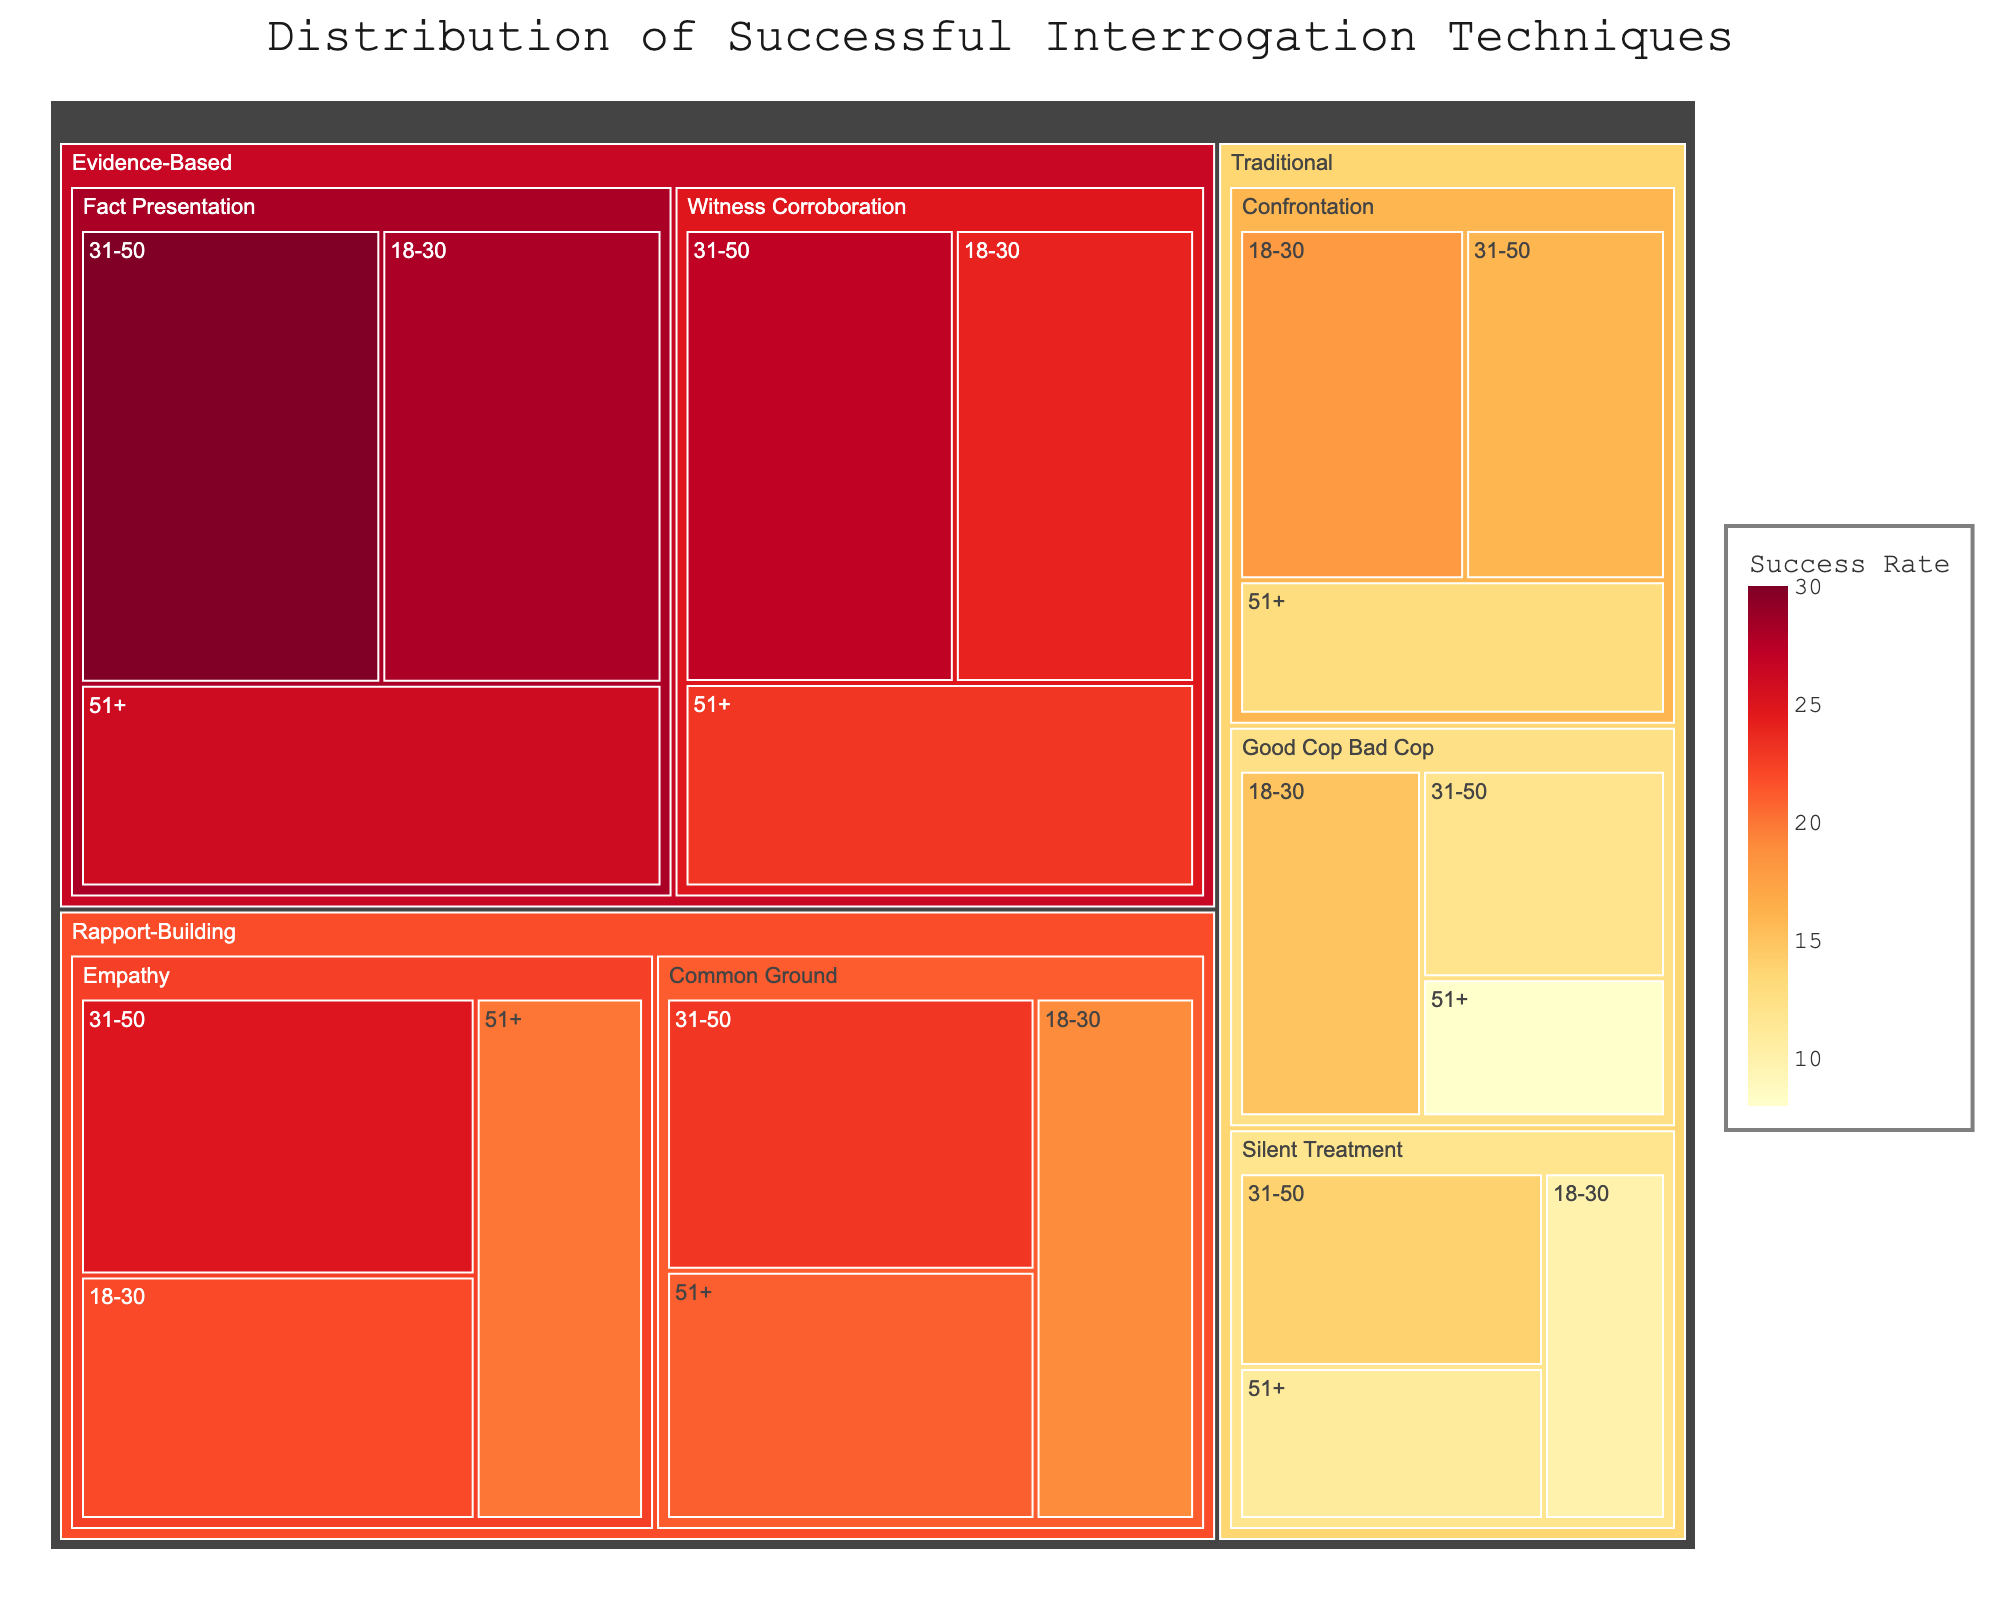What's the title of the figure? The title is usually at the top of the figure and can be read directly from there.
Answer: Distribution of Successful Interrogation Techniques How many interrogation techniques are shown in the figure? The figure categorizes techniques under each approach: Traditional (Good Cop Bad Cop, Silent Treatment, Confrontation), Rapport-Building (Empathy, Common Ground), and Evidence-Based (Fact Presentation, Witness Corroboration), totaling 6 techniques.
Answer: 6 Which approach shows the highest success rate on average? By comparing the color intensities for each approach and observing the overall trend, we can see that Evidence-Based approaches have the highest success rates on average.
Answer: Evidence-Based What is the success rate for the Fact Presentation technique for the age group 31-50? Locate the section for Evidence-Based techniques, then the Fact Presentation technique under that category, and refer to the age group 31-50.
Answer: 30 Which age group has the lowest success rate for Silent Treatment? Under Traditional approaches, find Silent Treatment, and compare the success rates for 18-30, 31-50, and 51+. The age group 51+ has the lowest success rate.
Answer: 51+ What is the cumulative success rate for all Traditional techniques for the age group 18-30? Summing the success rates for Good Cop Bad Cop (15), Silent Treatment (10), and Confrontation (18) in the 18-30 age group: 15 + 10 + 18 = 43.
Answer: 43 Compare the success rates between Good Cop Bad Cop and Empathy for the age group 18-30. Compare the success rates found under Traditional (Good Cop Bad Cop: 15) and Rapport-Building (Empathy: 22) for the 18-30 age group.
Answer: Empathy has a higher rate (22 vs. 15) Which technique has the most consistent success rate across all age groups? Looking at the variations, Empathy under Rapport-Building approaches has very consistent success rates across all age groups (22 for 18-30, 25 for 31-50, and 20 for 51+).
Answer: Empathy What's the average success rate for Witness Corroboration across all age groups? Sum the success rates for Witness Corroboration in each age group (24 for 18-30, 27 for 31-50, and 23 for 51+) and divide by 3. (24 + 27 + 23) / 3 = 24.67
Answer: 24.67 Which technique and age group combination has the highest success rate overall? Identify the highest value within the color intensity scale and check the corresponding section, which is Fact Presentation for the 31-50 age group.
Answer: Fact Presentation, 31-50 